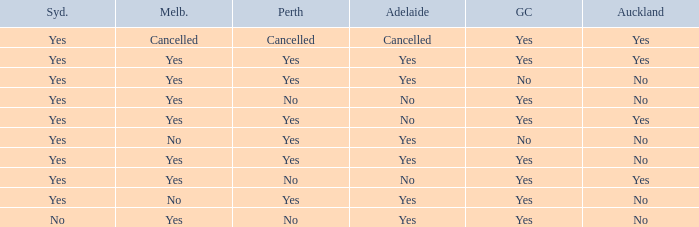What is the sydney that has adelaide, gold coast, melbourne, and auckland are all yes? Yes. Parse the full table. {'header': ['Syd.', 'Melb.', 'Perth', 'Adelaide', 'GC', 'Auckland'], 'rows': [['Yes', 'Cancelled', 'Cancelled', 'Cancelled', 'Yes', 'Yes'], ['Yes', 'Yes', 'Yes', 'Yes', 'Yes', 'Yes'], ['Yes', 'Yes', 'Yes', 'Yes', 'No', 'No'], ['Yes', 'Yes', 'No', 'No', 'Yes', 'No'], ['Yes', 'Yes', 'Yes', 'No', 'Yes', 'Yes'], ['Yes', 'No', 'Yes', 'Yes', 'No', 'No'], ['Yes', 'Yes', 'Yes', 'Yes', 'Yes', 'No'], ['Yes', 'Yes', 'No', 'No', 'Yes', 'Yes'], ['Yes', 'No', 'Yes', 'Yes', 'Yes', 'No'], ['No', 'Yes', 'No', 'Yes', 'Yes', 'No']]} 